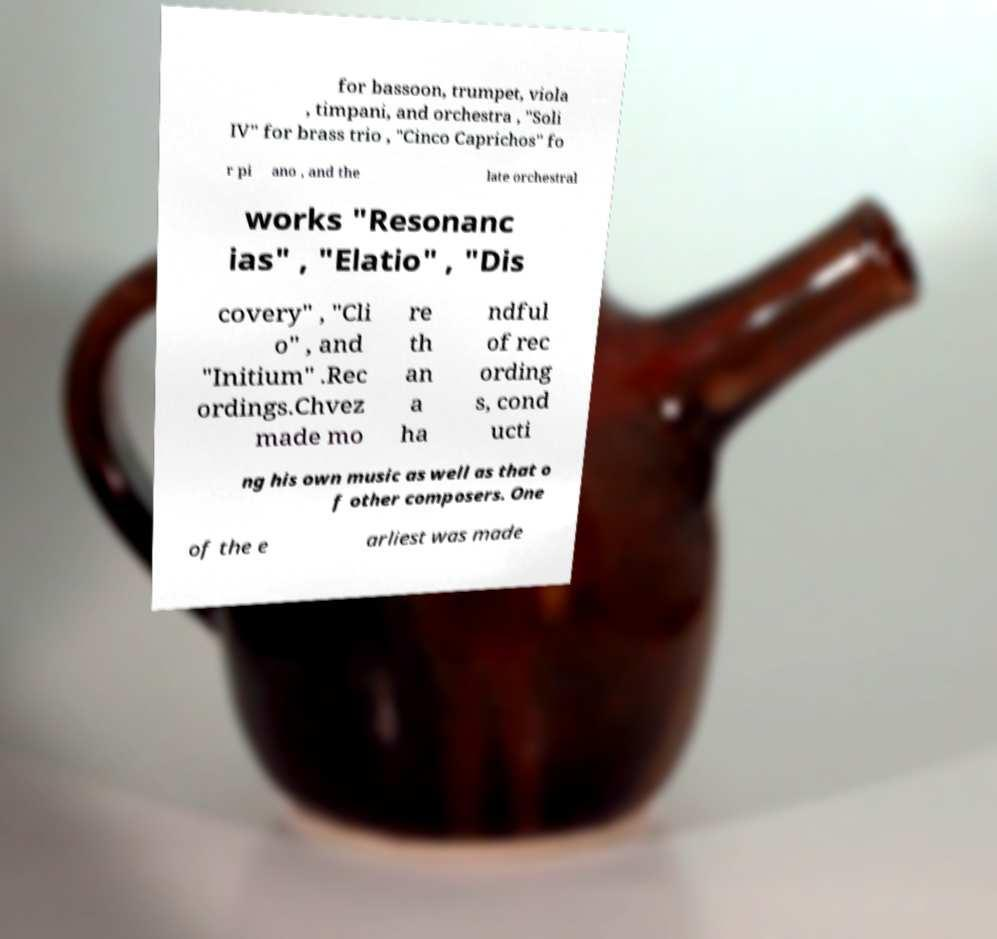Could you extract and type out the text from this image? for bassoon, trumpet, viola , timpani, and orchestra , "Soli IV" for brass trio , "Cinco Caprichos" fo r pi ano , and the late orchestral works "Resonanc ias" , "Elatio" , "Dis covery" , "Cli o" , and "Initium" .Rec ordings.Chvez made mo re th an a ha ndful of rec ording s, cond ucti ng his own music as well as that o f other composers. One of the e arliest was made 